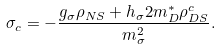<formula> <loc_0><loc_0><loc_500><loc_500>\sigma _ { c } = - \frac { g _ { \sigma } \rho _ { N S } + h _ { \sigma } 2 m _ { D } ^ { * } \rho _ { D S } ^ { c } } { m _ { \sigma } ^ { 2 } } .</formula> 